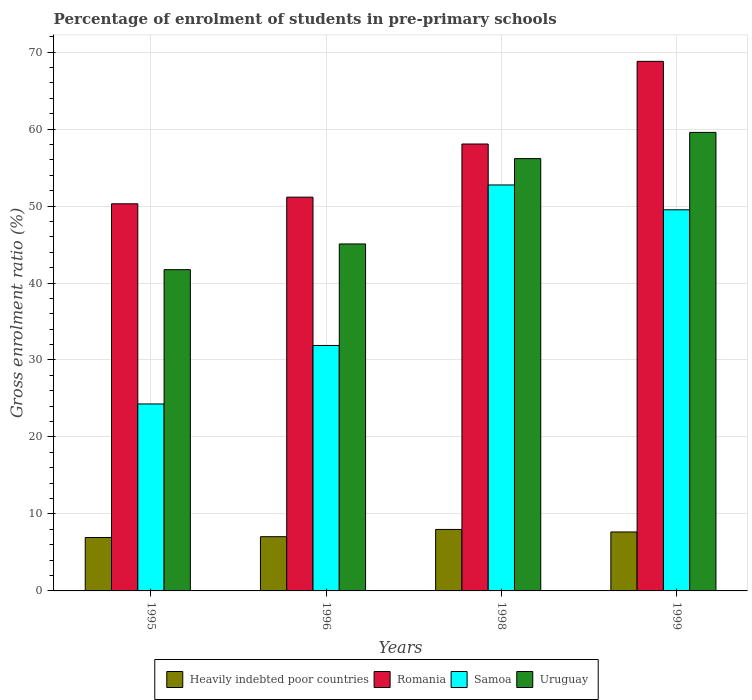How many different coloured bars are there?
Make the answer very short. 4. How many groups of bars are there?
Provide a succinct answer. 4. How many bars are there on the 1st tick from the left?
Offer a very short reply. 4. What is the label of the 2nd group of bars from the left?
Provide a short and direct response. 1996. What is the percentage of students enrolled in pre-primary schools in Uruguay in 1999?
Your answer should be very brief. 59.57. Across all years, what is the maximum percentage of students enrolled in pre-primary schools in Romania?
Provide a short and direct response. 68.79. Across all years, what is the minimum percentage of students enrolled in pre-primary schools in Heavily indebted poor countries?
Your answer should be compact. 6.94. In which year was the percentage of students enrolled in pre-primary schools in Samoa maximum?
Give a very brief answer. 1998. In which year was the percentage of students enrolled in pre-primary schools in Heavily indebted poor countries minimum?
Provide a succinct answer. 1995. What is the total percentage of students enrolled in pre-primary schools in Romania in the graph?
Ensure brevity in your answer.  228.29. What is the difference between the percentage of students enrolled in pre-primary schools in Heavily indebted poor countries in 1998 and that in 1999?
Ensure brevity in your answer.  0.33. What is the difference between the percentage of students enrolled in pre-primary schools in Samoa in 1998 and the percentage of students enrolled in pre-primary schools in Romania in 1999?
Give a very brief answer. -16.06. What is the average percentage of students enrolled in pre-primary schools in Romania per year?
Provide a short and direct response. 57.07. In the year 1996, what is the difference between the percentage of students enrolled in pre-primary schools in Uruguay and percentage of students enrolled in pre-primary schools in Heavily indebted poor countries?
Ensure brevity in your answer.  38.03. In how many years, is the percentage of students enrolled in pre-primary schools in Heavily indebted poor countries greater than 18 %?
Offer a very short reply. 0. What is the ratio of the percentage of students enrolled in pre-primary schools in Romania in 1998 to that in 1999?
Make the answer very short. 0.84. What is the difference between the highest and the second highest percentage of students enrolled in pre-primary schools in Heavily indebted poor countries?
Offer a very short reply. 0.33. What is the difference between the highest and the lowest percentage of students enrolled in pre-primary schools in Romania?
Your answer should be compact. 18.5. Is the sum of the percentage of students enrolled in pre-primary schools in Romania in 1996 and 1998 greater than the maximum percentage of students enrolled in pre-primary schools in Samoa across all years?
Your answer should be very brief. Yes. Is it the case that in every year, the sum of the percentage of students enrolled in pre-primary schools in Samoa and percentage of students enrolled in pre-primary schools in Heavily indebted poor countries is greater than the sum of percentage of students enrolled in pre-primary schools in Uruguay and percentage of students enrolled in pre-primary schools in Romania?
Make the answer very short. Yes. What does the 4th bar from the left in 1995 represents?
Make the answer very short. Uruguay. What does the 1st bar from the right in 1998 represents?
Provide a short and direct response. Uruguay. Are all the bars in the graph horizontal?
Provide a succinct answer. No. What is the difference between two consecutive major ticks on the Y-axis?
Provide a short and direct response. 10. Are the values on the major ticks of Y-axis written in scientific E-notation?
Offer a terse response. No. Where does the legend appear in the graph?
Provide a short and direct response. Bottom center. What is the title of the graph?
Keep it short and to the point. Percentage of enrolment of students in pre-primary schools. What is the label or title of the Y-axis?
Provide a short and direct response. Gross enrolment ratio (%). What is the Gross enrolment ratio (%) of Heavily indebted poor countries in 1995?
Provide a succinct answer. 6.94. What is the Gross enrolment ratio (%) of Romania in 1995?
Provide a short and direct response. 50.29. What is the Gross enrolment ratio (%) in Samoa in 1995?
Keep it short and to the point. 24.29. What is the Gross enrolment ratio (%) in Uruguay in 1995?
Provide a succinct answer. 41.73. What is the Gross enrolment ratio (%) in Heavily indebted poor countries in 1996?
Provide a succinct answer. 7.05. What is the Gross enrolment ratio (%) of Romania in 1996?
Provide a succinct answer. 51.15. What is the Gross enrolment ratio (%) in Samoa in 1996?
Your response must be concise. 31.89. What is the Gross enrolment ratio (%) of Uruguay in 1996?
Your response must be concise. 45.07. What is the Gross enrolment ratio (%) in Heavily indebted poor countries in 1998?
Ensure brevity in your answer.  7.99. What is the Gross enrolment ratio (%) of Romania in 1998?
Provide a succinct answer. 58.06. What is the Gross enrolment ratio (%) of Samoa in 1998?
Your response must be concise. 52.74. What is the Gross enrolment ratio (%) in Uruguay in 1998?
Provide a short and direct response. 56.16. What is the Gross enrolment ratio (%) in Heavily indebted poor countries in 1999?
Your answer should be compact. 7.66. What is the Gross enrolment ratio (%) in Romania in 1999?
Your answer should be compact. 68.79. What is the Gross enrolment ratio (%) of Samoa in 1999?
Give a very brief answer. 49.51. What is the Gross enrolment ratio (%) in Uruguay in 1999?
Keep it short and to the point. 59.57. Across all years, what is the maximum Gross enrolment ratio (%) of Heavily indebted poor countries?
Your response must be concise. 7.99. Across all years, what is the maximum Gross enrolment ratio (%) of Romania?
Provide a succinct answer. 68.79. Across all years, what is the maximum Gross enrolment ratio (%) of Samoa?
Ensure brevity in your answer.  52.74. Across all years, what is the maximum Gross enrolment ratio (%) of Uruguay?
Offer a very short reply. 59.57. Across all years, what is the minimum Gross enrolment ratio (%) in Heavily indebted poor countries?
Make the answer very short. 6.94. Across all years, what is the minimum Gross enrolment ratio (%) in Romania?
Keep it short and to the point. 50.29. Across all years, what is the minimum Gross enrolment ratio (%) in Samoa?
Your answer should be very brief. 24.29. Across all years, what is the minimum Gross enrolment ratio (%) in Uruguay?
Give a very brief answer. 41.73. What is the total Gross enrolment ratio (%) of Heavily indebted poor countries in the graph?
Provide a short and direct response. 29.63. What is the total Gross enrolment ratio (%) of Romania in the graph?
Your answer should be compact. 228.29. What is the total Gross enrolment ratio (%) in Samoa in the graph?
Make the answer very short. 158.42. What is the total Gross enrolment ratio (%) in Uruguay in the graph?
Provide a succinct answer. 202.53. What is the difference between the Gross enrolment ratio (%) of Heavily indebted poor countries in 1995 and that in 1996?
Keep it short and to the point. -0.11. What is the difference between the Gross enrolment ratio (%) in Romania in 1995 and that in 1996?
Your answer should be compact. -0.86. What is the difference between the Gross enrolment ratio (%) in Samoa in 1995 and that in 1996?
Keep it short and to the point. -7.6. What is the difference between the Gross enrolment ratio (%) of Uruguay in 1995 and that in 1996?
Keep it short and to the point. -3.34. What is the difference between the Gross enrolment ratio (%) of Heavily indebted poor countries in 1995 and that in 1998?
Make the answer very short. -1.05. What is the difference between the Gross enrolment ratio (%) of Romania in 1995 and that in 1998?
Your response must be concise. -7.77. What is the difference between the Gross enrolment ratio (%) of Samoa in 1995 and that in 1998?
Provide a short and direct response. -28.45. What is the difference between the Gross enrolment ratio (%) of Uruguay in 1995 and that in 1998?
Keep it short and to the point. -14.43. What is the difference between the Gross enrolment ratio (%) of Heavily indebted poor countries in 1995 and that in 1999?
Offer a very short reply. -0.72. What is the difference between the Gross enrolment ratio (%) in Romania in 1995 and that in 1999?
Give a very brief answer. -18.5. What is the difference between the Gross enrolment ratio (%) of Samoa in 1995 and that in 1999?
Your answer should be very brief. -25.22. What is the difference between the Gross enrolment ratio (%) in Uruguay in 1995 and that in 1999?
Provide a succinct answer. -17.83. What is the difference between the Gross enrolment ratio (%) in Heavily indebted poor countries in 1996 and that in 1998?
Keep it short and to the point. -0.94. What is the difference between the Gross enrolment ratio (%) of Romania in 1996 and that in 1998?
Give a very brief answer. -6.9. What is the difference between the Gross enrolment ratio (%) in Samoa in 1996 and that in 1998?
Your answer should be very brief. -20.85. What is the difference between the Gross enrolment ratio (%) in Uruguay in 1996 and that in 1998?
Give a very brief answer. -11.09. What is the difference between the Gross enrolment ratio (%) of Heavily indebted poor countries in 1996 and that in 1999?
Make the answer very short. -0.61. What is the difference between the Gross enrolment ratio (%) in Romania in 1996 and that in 1999?
Give a very brief answer. -17.64. What is the difference between the Gross enrolment ratio (%) of Samoa in 1996 and that in 1999?
Your answer should be compact. -17.62. What is the difference between the Gross enrolment ratio (%) of Uruguay in 1996 and that in 1999?
Provide a short and direct response. -14.49. What is the difference between the Gross enrolment ratio (%) in Heavily indebted poor countries in 1998 and that in 1999?
Make the answer very short. 0.33. What is the difference between the Gross enrolment ratio (%) in Romania in 1998 and that in 1999?
Ensure brevity in your answer.  -10.74. What is the difference between the Gross enrolment ratio (%) in Samoa in 1998 and that in 1999?
Your response must be concise. 3.23. What is the difference between the Gross enrolment ratio (%) of Uruguay in 1998 and that in 1999?
Offer a terse response. -3.41. What is the difference between the Gross enrolment ratio (%) in Heavily indebted poor countries in 1995 and the Gross enrolment ratio (%) in Romania in 1996?
Ensure brevity in your answer.  -44.21. What is the difference between the Gross enrolment ratio (%) of Heavily indebted poor countries in 1995 and the Gross enrolment ratio (%) of Samoa in 1996?
Ensure brevity in your answer.  -24.95. What is the difference between the Gross enrolment ratio (%) in Heavily indebted poor countries in 1995 and the Gross enrolment ratio (%) in Uruguay in 1996?
Your response must be concise. -38.13. What is the difference between the Gross enrolment ratio (%) in Romania in 1995 and the Gross enrolment ratio (%) in Samoa in 1996?
Offer a very short reply. 18.4. What is the difference between the Gross enrolment ratio (%) in Romania in 1995 and the Gross enrolment ratio (%) in Uruguay in 1996?
Ensure brevity in your answer.  5.21. What is the difference between the Gross enrolment ratio (%) in Samoa in 1995 and the Gross enrolment ratio (%) in Uruguay in 1996?
Keep it short and to the point. -20.79. What is the difference between the Gross enrolment ratio (%) in Heavily indebted poor countries in 1995 and the Gross enrolment ratio (%) in Romania in 1998?
Offer a very short reply. -51.12. What is the difference between the Gross enrolment ratio (%) of Heavily indebted poor countries in 1995 and the Gross enrolment ratio (%) of Samoa in 1998?
Ensure brevity in your answer.  -45.8. What is the difference between the Gross enrolment ratio (%) in Heavily indebted poor countries in 1995 and the Gross enrolment ratio (%) in Uruguay in 1998?
Keep it short and to the point. -49.22. What is the difference between the Gross enrolment ratio (%) of Romania in 1995 and the Gross enrolment ratio (%) of Samoa in 1998?
Offer a very short reply. -2.45. What is the difference between the Gross enrolment ratio (%) of Romania in 1995 and the Gross enrolment ratio (%) of Uruguay in 1998?
Your answer should be compact. -5.87. What is the difference between the Gross enrolment ratio (%) in Samoa in 1995 and the Gross enrolment ratio (%) in Uruguay in 1998?
Make the answer very short. -31.87. What is the difference between the Gross enrolment ratio (%) in Heavily indebted poor countries in 1995 and the Gross enrolment ratio (%) in Romania in 1999?
Provide a short and direct response. -61.85. What is the difference between the Gross enrolment ratio (%) of Heavily indebted poor countries in 1995 and the Gross enrolment ratio (%) of Samoa in 1999?
Provide a short and direct response. -42.57. What is the difference between the Gross enrolment ratio (%) of Heavily indebted poor countries in 1995 and the Gross enrolment ratio (%) of Uruguay in 1999?
Your answer should be compact. -52.63. What is the difference between the Gross enrolment ratio (%) of Romania in 1995 and the Gross enrolment ratio (%) of Samoa in 1999?
Provide a short and direct response. 0.78. What is the difference between the Gross enrolment ratio (%) of Romania in 1995 and the Gross enrolment ratio (%) of Uruguay in 1999?
Make the answer very short. -9.28. What is the difference between the Gross enrolment ratio (%) of Samoa in 1995 and the Gross enrolment ratio (%) of Uruguay in 1999?
Give a very brief answer. -35.28. What is the difference between the Gross enrolment ratio (%) of Heavily indebted poor countries in 1996 and the Gross enrolment ratio (%) of Romania in 1998?
Offer a very short reply. -51.01. What is the difference between the Gross enrolment ratio (%) in Heavily indebted poor countries in 1996 and the Gross enrolment ratio (%) in Samoa in 1998?
Offer a terse response. -45.69. What is the difference between the Gross enrolment ratio (%) of Heavily indebted poor countries in 1996 and the Gross enrolment ratio (%) of Uruguay in 1998?
Your answer should be very brief. -49.11. What is the difference between the Gross enrolment ratio (%) of Romania in 1996 and the Gross enrolment ratio (%) of Samoa in 1998?
Offer a very short reply. -1.58. What is the difference between the Gross enrolment ratio (%) in Romania in 1996 and the Gross enrolment ratio (%) in Uruguay in 1998?
Your answer should be very brief. -5.01. What is the difference between the Gross enrolment ratio (%) in Samoa in 1996 and the Gross enrolment ratio (%) in Uruguay in 1998?
Give a very brief answer. -24.27. What is the difference between the Gross enrolment ratio (%) of Heavily indebted poor countries in 1996 and the Gross enrolment ratio (%) of Romania in 1999?
Offer a very short reply. -61.75. What is the difference between the Gross enrolment ratio (%) in Heavily indebted poor countries in 1996 and the Gross enrolment ratio (%) in Samoa in 1999?
Your answer should be compact. -42.47. What is the difference between the Gross enrolment ratio (%) of Heavily indebted poor countries in 1996 and the Gross enrolment ratio (%) of Uruguay in 1999?
Ensure brevity in your answer.  -52.52. What is the difference between the Gross enrolment ratio (%) of Romania in 1996 and the Gross enrolment ratio (%) of Samoa in 1999?
Keep it short and to the point. 1.64. What is the difference between the Gross enrolment ratio (%) of Romania in 1996 and the Gross enrolment ratio (%) of Uruguay in 1999?
Provide a succinct answer. -8.42. What is the difference between the Gross enrolment ratio (%) of Samoa in 1996 and the Gross enrolment ratio (%) of Uruguay in 1999?
Your answer should be very brief. -27.68. What is the difference between the Gross enrolment ratio (%) of Heavily indebted poor countries in 1998 and the Gross enrolment ratio (%) of Romania in 1999?
Ensure brevity in your answer.  -60.81. What is the difference between the Gross enrolment ratio (%) of Heavily indebted poor countries in 1998 and the Gross enrolment ratio (%) of Samoa in 1999?
Your answer should be compact. -41.53. What is the difference between the Gross enrolment ratio (%) of Heavily indebted poor countries in 1998 and the Gross enrolment ratio (%) of Uruguay in 1999?
Provide a short and direct response. -51.58. What is the difference between the Gross enrolment ratio (%) of Romania in 1998 and the Gross enrolment ratio (%) of Samoa in 1999?
Your answer should be compact. 8.55. What is the difference between the Gross enrolment ratio (%) in Romania in 1998 and the Gross enrolment ratio (%) in Uruguay in 1999?
Provide a short and direct response. -1.51. What is the difference between the Gross enrolment ratio (%) of Samoa in 1998 and the Gross enrolment ratio (%) of Uruguay in 1999?
Offer a terse response. -6.83. What is the average Gross enrolment ratio (%) in Heavily indebted poor countries per year?
Make the answer very short. 7.41. What is the average Gross enrolment ratio (%) in Romania per year?
Provide a succinct answer. 57.07. What is the average Gross enrolment ratio (%) of Samoa per year?
Offer a very short reply. 39.61. What is the average Gross enrolment ratio (%) in Uruguay per year?
Your response must be concise. 50.63. In the year 1995, what is the difference between the Gross enrolment ratio (%) in Heavily indebted poor countries and Gross enrolment ratio (%) in Romania?
Keep it short and to the point. -43.35. In the year 1995, what is the difference between the Gross enrolment ratio (%) in Heavily indebted poor countries and Gross enrolment ratio (%) in Samoa?
Provide a short and direct response. -17.35. In the year 1995, what is the difference between the Gross enrolment ratio (%) in Heavily indebted poor countries and Gross enrolment ratio (%) in Uruguay?
Keep it short and to the point. -34.79. In the year 1995, what is the difference between the Gross enrolment ratio (%) of Romania and Gross enrolment ratio (%) of Samoa?
Give a very brief answer. 26. In the year 1995, what is the difference between the Gross enrolment ratio (%) in Romania and Gross enrolment ratio (%) in Uruguay?
Offer a very short reply. 8.56. In the year 1995, what is the difference between the Gross enrolment ratio (%) in Samoa and Gross enrolment ratio (%) in Uruguay?
Provide a short and direct response. -17.44. In the year 1996, what is the difference between the Gross enrolment ratio (%) in Heavily indebted poor countries and Gross enrolment ratio (%) in Romania?
Make the answer very short. -44.11. In the year 1996, what is the difference between the Gross enrolment ratio (%) in Heavily indebted poor countries and Gross enrolment ratio (%) in Samoa?
Provide a succinct answer. -24.84. In the year 1996, what is the difference between the Gross enrolment ratio (%) in Heavily indebted poor countries and Gross enrolment ratio (%) in Uruguay?
Your answer should be very brief. -38.03. In the year 1996, what is the difference between the Gross enrolment ratio (%) of Romania and Gross enrolment ratio (%) of Samoa?
Give a very brief answer. 19.27. In the year 1996, what is the difference between the Gross enrolment ratio (%) of Romania and Gross enrolment ratio (%) of Uruguay?
Provide a short and direct response. 6.08. In the year 1996, what is the difference between the Gross enrolment ratio (%) of Samoa and Gross enrolment ratio (%) of Uruguay?
Offer a terse response. -13.19. In the year 1998, what is the difference between the Gross enrolment ratio (%) of Heavily indebted poor countries and Gross enrolment ratio (%) of Romania?
Your answer should be very brief. -50.07. In the year 1998, what is the difference between the Gross enrolment ratio (%) of Heavily indebted poor countries and Gross enrolment ratio (%) of Samoa?
Offer a terse response. -44.75. In the year 1998, what is the difference between the Gross enrolment ratio (%) in Heavily indebted poor countries and Gross enrolment ratio (%) in Uruguay?
Provide a short and direct response. -48.17. In the year 1998, what is the difference between the Gross enrolment ratio (%) in Romania and Gross enrolment ratio (%) in Samoa?
Offer a very short reply. 5.32. In the year 1998, what is the difference between the Gross enrolment ratio (%) in Romania and Gross enrolment ratio (%) in Uruguay?
Give a very brief answer. 1.9. In the year 1998, what is the difference between the Gross enrolment ratio (%) in Samoa and Gross enrolment ratio (%) in Uruguay?
Ensure brevity in your answer.  -3.42. In the year 1999, what is the difference between the Gross enrolment ratio (%) of Heavily indebted poor countries and Gross enrolment ratio (%) of Romania?
Provide a short and direct response. -61.13. In the year 1999, what is the difference between the Gross enrolment ratio (%) of Heavily indebted poor countries and Gross enrolment ratio (%) of Samoa?
Ensure brevity in your answer.  -41.85. In the year 1999, what is the difference between the Gross enrolment ratio (%) of Heavily indebted poor countries and Gross enrolment ratio (%) of Uruguay?
Ensure brevity in your answer.  -51.91. In the year 1999, what is the difference between the Gross enrolment ratio (%) of Romania and Gross enrolment ratio (%) of Samoa?
Offer a very short reply. 19.28. In the year 1999, what is the difference between the Gross enrolment ratio (%) of Romania and Gross enrolment ratio (%) of Uruguay?
Ensure brevity in your answer.  9.23. In the year 1999, what is the difference between the Gross enrolment ratio (%) of Samoa and Gross enrolment ratio (%) of Uruguay?
Provide a short and direct response. -10.06. What is the ratio of the Gross enrolment ratio (%) in Romania in 1995 to that in 1996?
Make the answer very short. 0.98. What is the ratio of the Gross enrolment ratio (%) in Samoa in 1995 to that in 1996?
Offer a terse response. 0.76. What is the ratio of the Gross enrolment ratio (%) of Uruguay in 1995 to that in 1996?
Offer a very short reply. 0.93. What is the ratio of the Gross enrolment ratio (%) of Heavily indebted poor countries in 1995 to that in 1998?
Ensure brevity in your answer.  0.87. What is the ratio of the Gross enrolment ratio (%) of Romania in 1995 to that in 1998?
Offer a very short reply. 0.87. What is the ratio of the Gross enrolment ratio (%) of Samoa in 1995 to that in 1998?
Provide a succinct answer. 0.46. What is the ratio of the Gross enrolment ratio (%) of Uruguay in 1995 to that in 1998?
Keep it short and to the point. 0.74. What is the ratio of the Gross enrolment ratio (%) in Heavily indebted poor countries in 1995 to that in 1999?
Your answer should be very brief. 0.91. What is the ratio of the Gross enrolment ratio (%) in Romania in 1995 to that in 1999?
Provide a succinct answer. 0.73. What is the ratio of the Gross enrolment ratio (%) in Samoa in 1995 to that in 1999?
Your answer should be very brief. 0.49. What is the ratio of the Gross enrolment ratio (%) of Uruguay in 1995 to that in 1999?
Provide a succinct answer. 0.7. What is the ratio of the Gross enrolment ratio (%) of Heavily indebted poor countries in 1996 to that in 1998?
Your answer should be very brief. 0.88. What is the ratio of the Gross enrolment ratio (%) in Romania in 1996 to that in 1998?
Make the answer very short. 0.88. What is the ratio of the Gross enrolment ratio (%) in Samoa in 1996 to that in 1998?
Ensure brevity in your answer.  0.6. What is the ratio of the Gross enrolment ratio (%) in Uruguay in 1996 to that in 1998?
Your answer should be compact. 0.8. What is the ratio of the Gross enrolment ratio (%) in Heavily indebted poor countries in 1996 to that in 1999?
Your answer should be compact. 0.92. What is the ratio of the Gross enrolment ratio (%) in Romania in 1996 to that in 1999?
Offer a terse response. 0.74. What is the ratio of the Gross enrolment ratio (%) of Samoa in 1996 to that in 1999?
Keep it short and to the point. 0.64. What is the ratio of the Gross enrolment ratio (%) of Uruguay in 1996 to that in 1999?
Provide a short and direct response. 0.76. What is the ratio of the Gross enrolment ratio (%) of Heavily indebted poor countries in 1998 to that in 1999?
Your answer should be compact. 1.04. What is the ratio of the Gross enrolment ratio (%) of Romania in 1998 to that in 1999?
Offer a terse response. 0.84. What is the ratio of the Gross enrolment ratio (%) of Samoa in 1998 to that in 1999?
Provide a short and direct response. 1.07. What is the ratio of the Gross enrolment ratio (%) of Uruguay in 1998 to that in 1999?
Ensure brevity in your answer.  0.94. What is the difference between the highest and the second highest Gross enrolment ratio (%) in Heavily indebted poor countries?
Your answer should be compact. 0.33. What is the difference between the highest and the second highest Gross enrolment ratio (%) of Romania?
Your answer should be compact. 10.74. What is the difference between the highest and the second highest Gross enrolment ratio (%) in Samoa?
Give a very brief answer. 3.23. What is the difference between the highest and the second highest Gross enrolment ratio (%) in Uruguay?
Give a very brief answer. 3.41. What is the difference between the highest and the lowest Gross enrolment ratio (%) in Heavily indebted poor countries?
Your answer should be very brief. 1.05. What is the difference between the highest and the lowest Gross enrolment ratio (%) in Romania?
Your answer should be compact. 18.5. What is the difference between the highest and the lowest Gross enrolment ratio (%) in Samoa?
Make the answer very short. 28.45. What is the difference between the highest and the lowest Gross enrolment ratio (%) in Uruguay?
Your answer should be very brief. 17.83. 